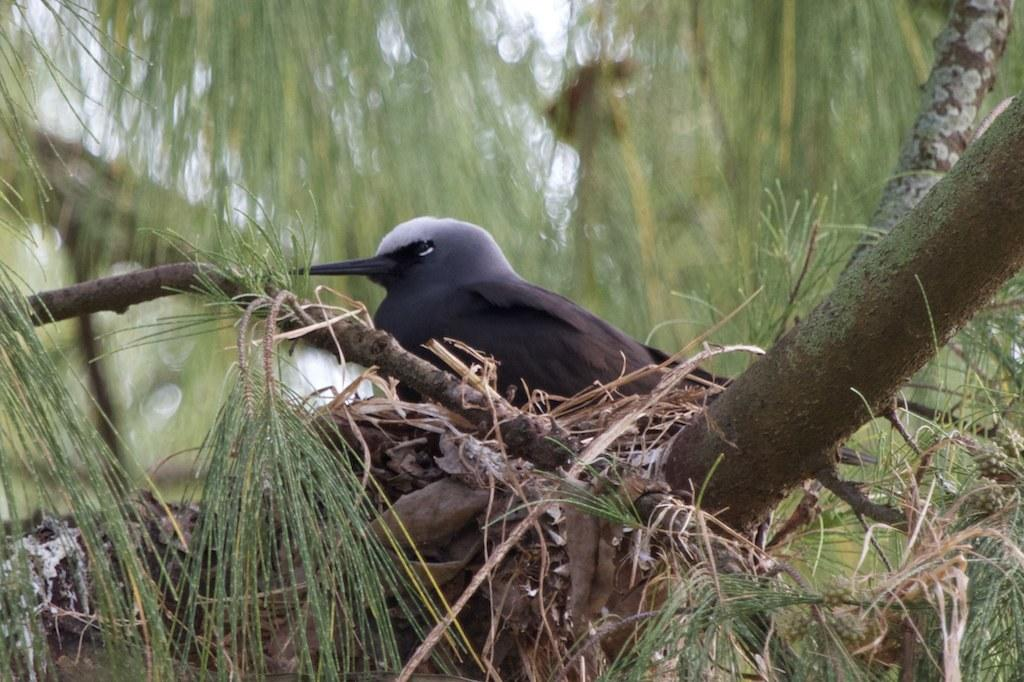What type of animal can be seen in the image? There is a bird in the image. Where is the bird located? The bird is in a nest. Can you describe the background of the image? The background of the image is blurred. How many houses are visible in the image? There are no houses visible in the image; it features a bird in a nest with a blurred background. What type of ticket can be seen in the image? There is no ticket present in the image. 